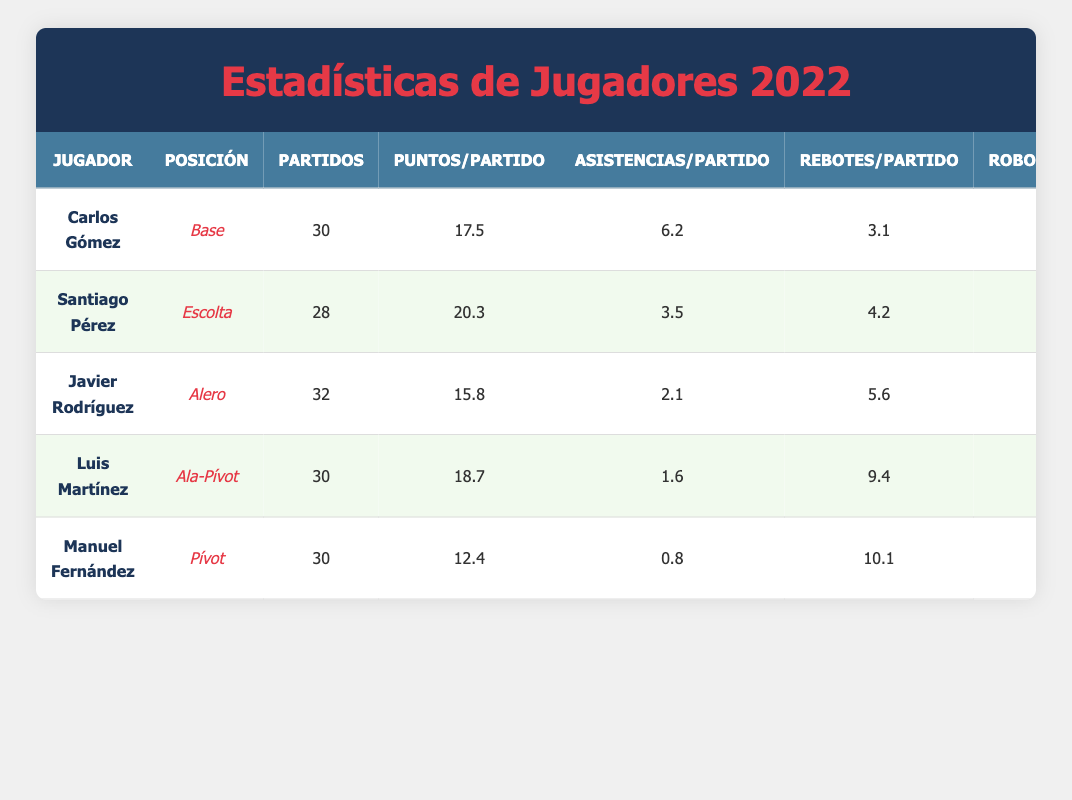What is the highest points per game recorded among players? Santiago Pérez has the highest points per game value at 20.3. We can find this by reviewing the "Puntos/Partido" column in the table and identifying the highest number among the players.
Answer: 20.3 How many games did Carlos Gómez play? Carlos Gómez played 30 games, as indicated in the "Partidos" column of his row in the table.
Answer: 30 What is the average rebounds per game for all players? To find the average rebounds per game, we sum the rebounds of all players: (3.1 + 4.2 + 5.6 + 9.4 + 10.1) = 32.4 and divide by the number of players (5), resulting in 32.4 / 5 = 6.48.
Answer: 6.48 Did any player have more than 2 turnovers per game? Yes, Carlos Gómez had 2.4 turnovers per game, which is greater than 2. This information is directly from the "Pérdidas/Partido" column.
Answer: Yes Who has the most assists per game among all players? Carlos Gómez has the most assists per game, with a total of 6.2. We refer to the "Asistencias/Partido" column and compare the values.
Answer: 6.2 What is the total number of assists made by Luis Martínez if he played all his games? Luis Martínez has an average of 1.6 assists per game. Assuming he played the full 30 games, we multiply 1.6 by 30 (1.6 * 30 = 48) to determine the total assists.
Answer: 48 Which player had the highest rebounds per game? Manuel Fernández had the highest rebounds per game with a total of 10.1, as seen in the "Rebotes/Partido" column.
Answer: 10.1 Is the average points per game for the guards (Carlos Gómez and Santiago Pérez) greater than 18? Yes, Carlos Gómez averages 17.5 and Santiago Pérez averages 20.3. The average for the two guards is (17.5 + 20.3) / 2 = 18.9, which is greater than 18.
Answer: Yes Which position player has the lowest points per game? Manuel Fernández, who plays as a Center, has the lowest points per game at 12.4, according to the "Puntos/Partido" column.
Answer: 12.4 